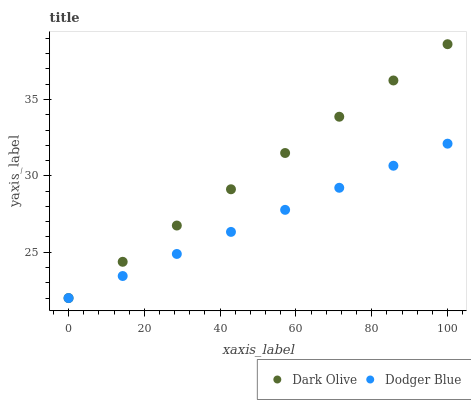Does Dodger Blue have the minimum area under the curve?
Answer yes or no. Yes. Does Dark Olive have the maximum area under the curve?
Answer yes or no. Yes. Does Dodger Blue have the maximum area under the curve?
Answer yes or no. No. Is Dark Olive the smoothest?
Answer yes or no. Yes. Is Dodger Blue the roughest?
Answer yes or no. Yes. Is Dodger Blue the smoothest?
Answer yes or no. No. Does Dark Olive have the lowest value?
Answer yes or no. Yes. Does Dark Olive have the highest value?
Answer yes or no. Yes. Does Dodger Blue have the highest value?
Answer yes or no. No. Does Dark Olive intersect Dodger Blue?
Answer yes or no. Yes. Is Dark Olive less than Dodger Blue?
Answer yes or no. No. Is Dark Olive greater than Dodger Blue?
Answer yes or no. No. 